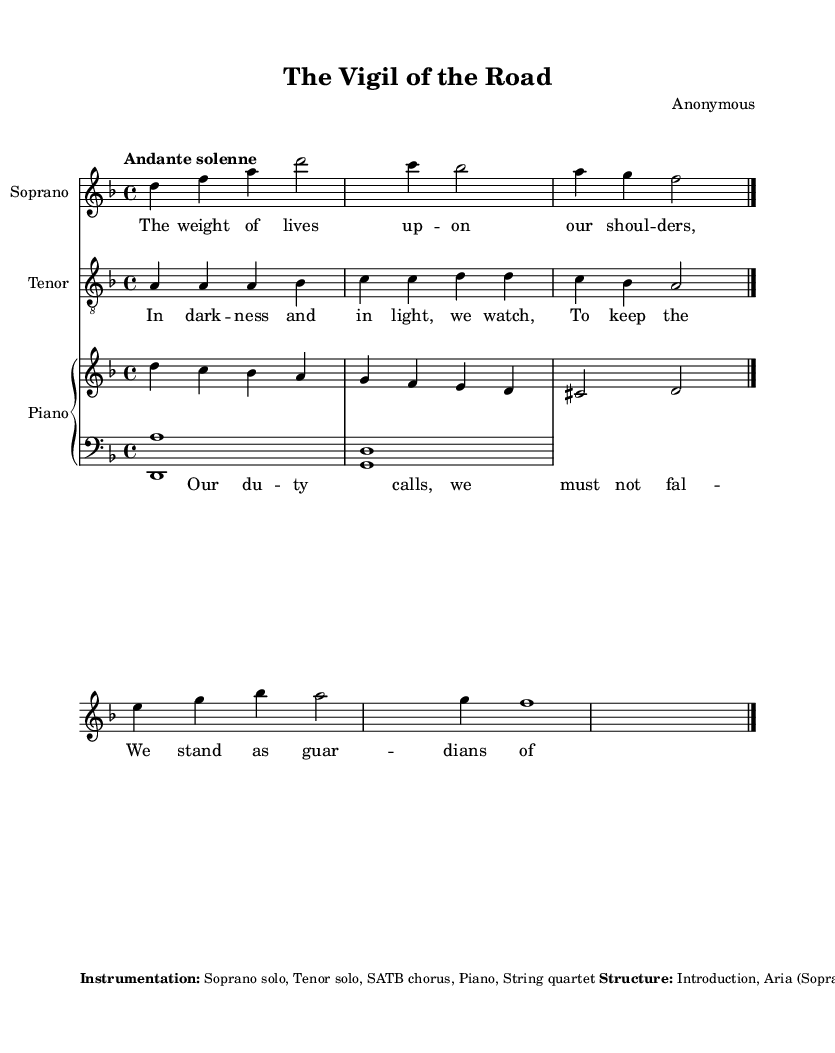What is the key signature of this music? The key signature is D minor, which is indicated by one flat (B♭) in the key signature.
Answer: D minor What is the time signature? The time signature is 4/4, which means there are four beats in each measure and the quarter note gets one beat.
Answer: 4/4 What is the tempo marking? The tempo marking is "Andante solenne," suggesting a slow, solemn pace for the piece.
Answer: Andante solenne What is the primary form of the piece? The piece primarily follows an operatic structure including an aria, recitative, duet, and chorus, indicating narrative development.
Answer: Introduction, Aria, Chorus, Recitative, Duet, Final Chorus How many vocal parts are featured in this opera? The opera features three vocal parts: Soprano, Tenor, and a SATB chorus, as indicated in the instrumentation.
Answer: Three What musical element represents the theme of duty? The piece uses descending melodic lines to symbolize the weight of duty, while ascending lines depict moments of resolve.
Answer: Descending melodic lines What does the duet's lyrics suggest about public service? The duet's lyrics convey a sense of commitment and resilience in their duty, emphasizing the responsibility of keeping travelers safe.
Answer: Commitment and resilience 